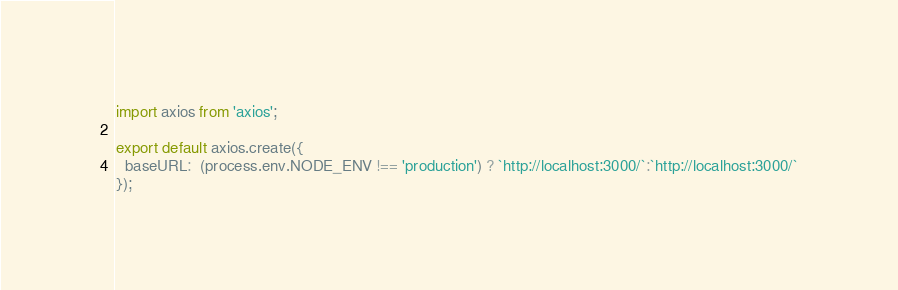Convert code to text. <code><loc_0><loc_0><loc_500><loc_500><_JavaScript_>import axios from 'axios';

export default axios.create({
  baseURL:  (process.env.NODE_ENV !== 'production') ? `http://localhost:3000/`:`http://localhost:3000/`
});</code> 